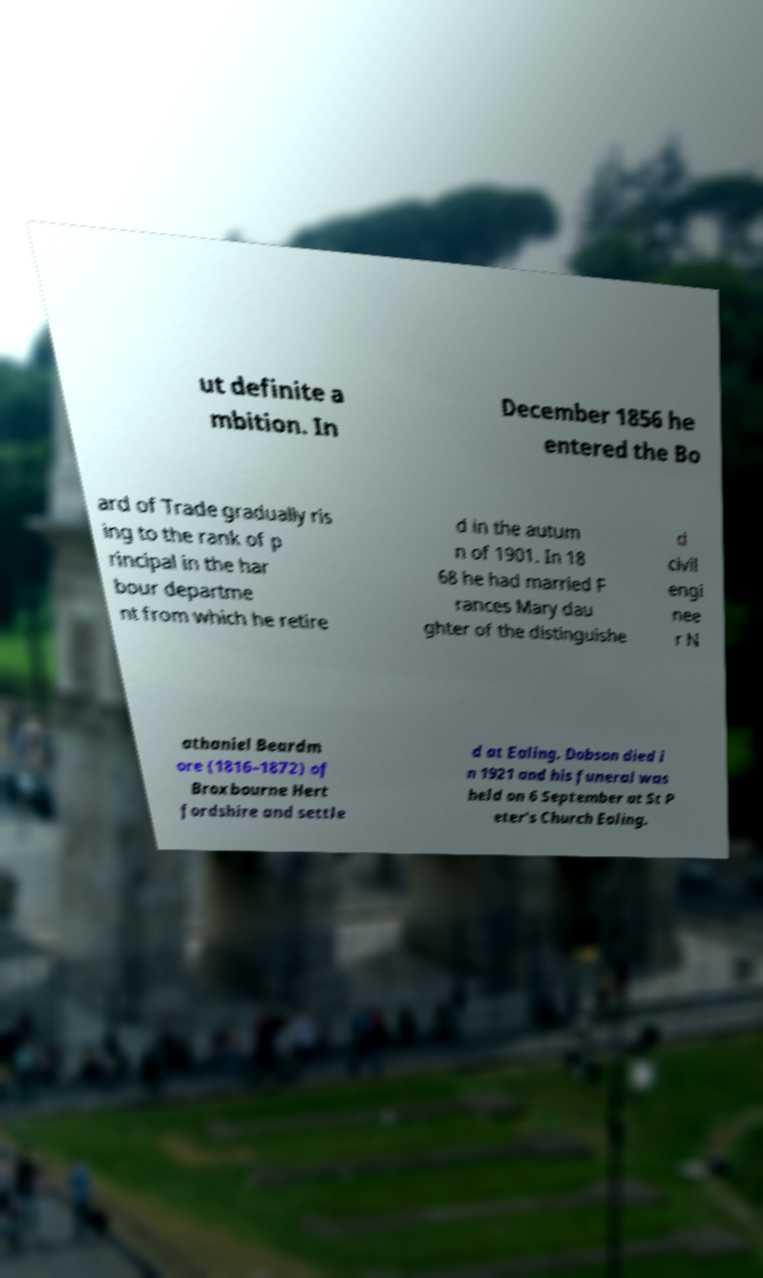Please read and relay the text visible in this image. What does it say? ut definite a mbition. In December 1856 he entered the Bo ard of Trade gradually ris ing to the rank of p rincipal in the har bour departme nt from which he retire d in the autum n of 1901. In 18 68 he had married F rances Mary dau ghter of the distinguishe d civil engi nee r N athaniel Beardm ore (1816–1872) of Broxbourne Hert fordshire and settle d at Ealing. Dobson died i n 1921 and his funeral was held on 6 September at St P eter's Church Ealing. 